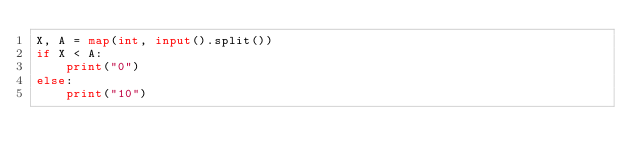<code> <loc_0><loc_0><loc_500><loc_500><_Python_>X, A = map(int, input().split())
if X < A:
    print("0")
else:
    print("10")</code> 